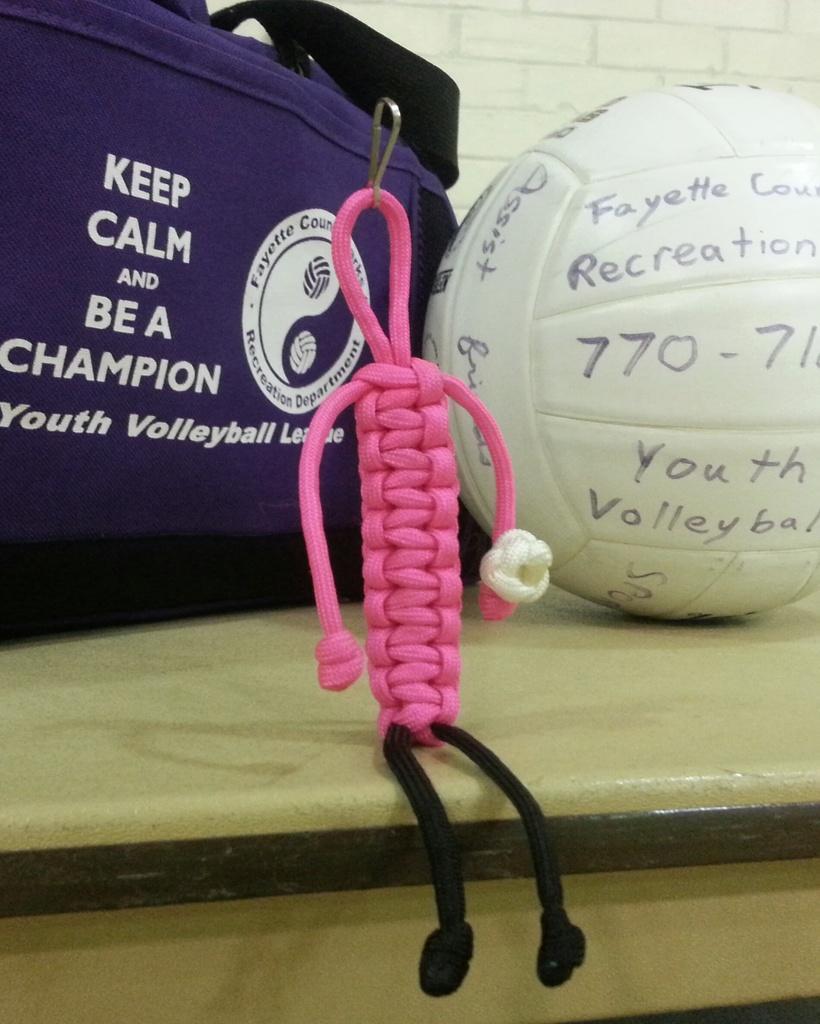Could you give a brief overview of what you see in this image? In this image there is a ball, bag, wall, thread crafting, wall and table. Something is written on the ball and bag. 